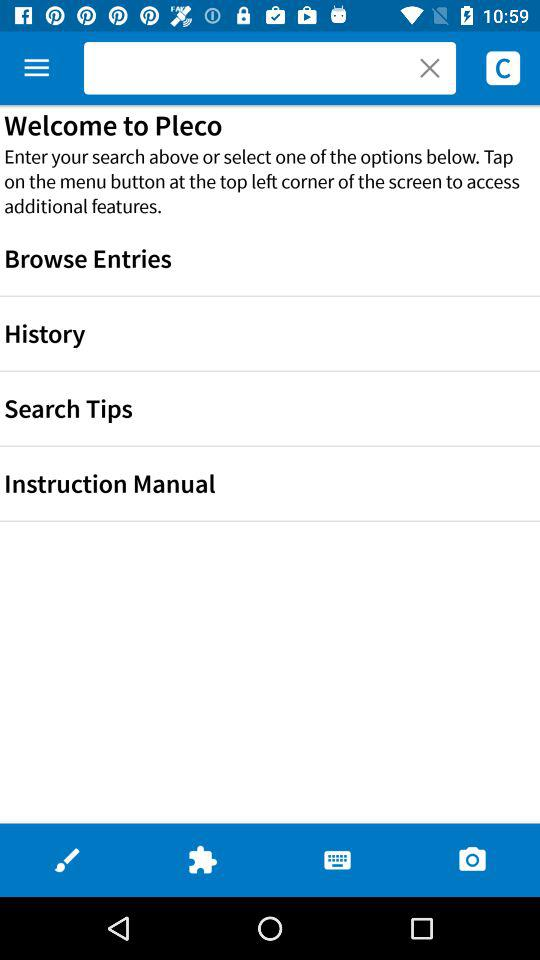Is "History" checked or unchecked?
When the provided information is insufficient, respond with <no answer>. <no answer> 